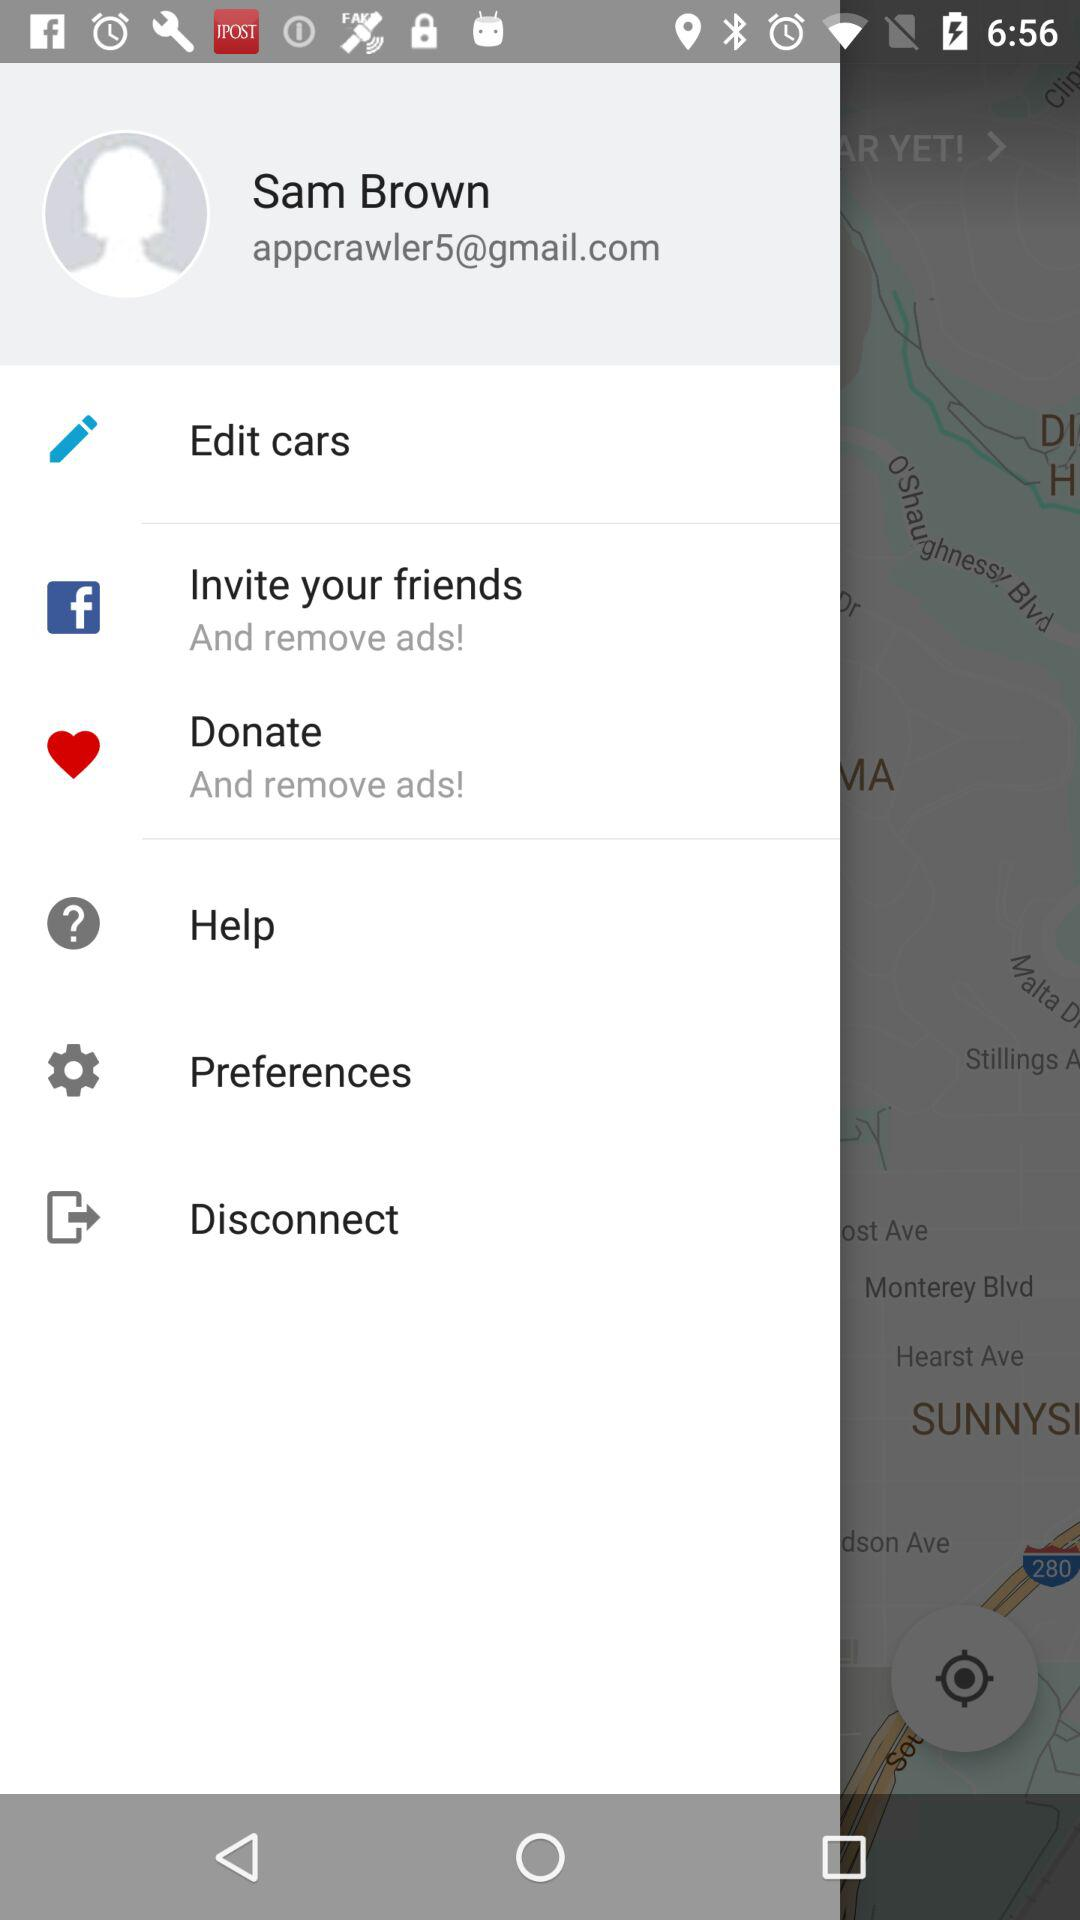What is the email address? The email address is appcrawler5@gmail.com. 